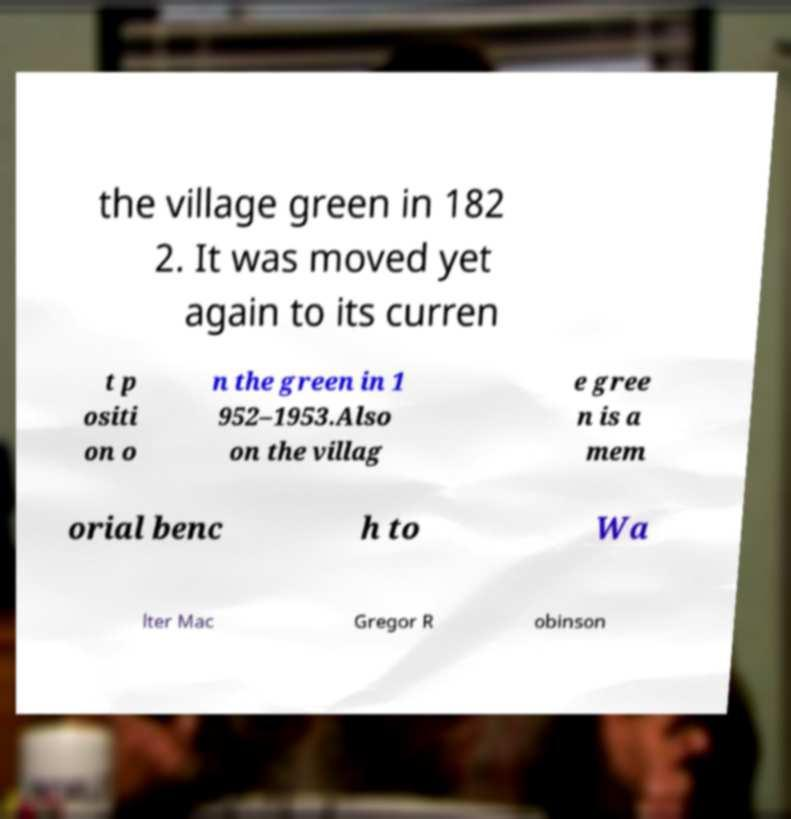I need the written content from this picture converted into text. Can you do that? the village green in 182 2. It was moved yet again to its curren t p ositi on o n the green in 1 952–1953.Also on the villag e gree n is a mem orial benc h to Wa lter Mac Gregor R obinson 